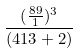Convert formula to latex. <formula><loc_0><loc_0><loc_500><loc_500>\frac { ( \frac { 8 9 } { 1 } ) ^ { 3 } } { ( 4 1 3 + 2 ) }</formula> 